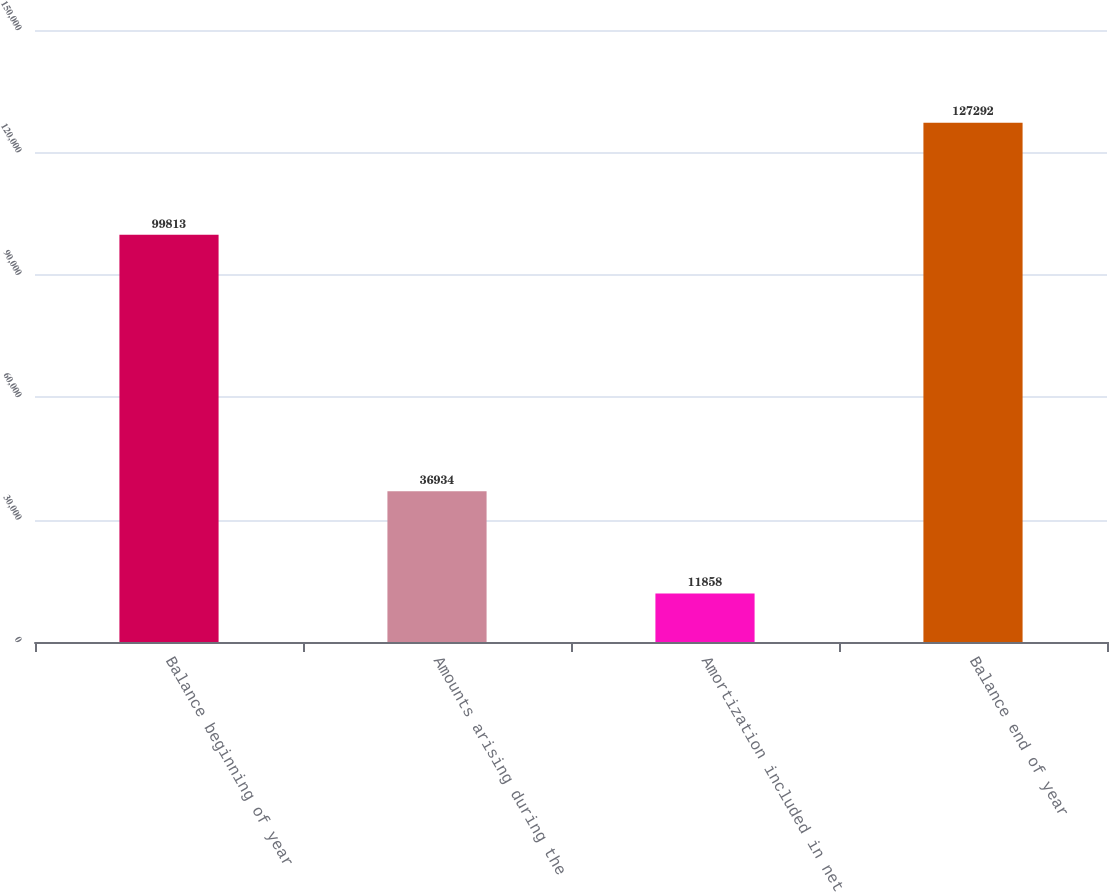<chart> <loc_0><loc_0><loc_500><loc_500><bar_chart><fcel>Balance beginning of year<fcel>Amounts arising during the<fcel>Amortization included in net<fcel>Balance end of year<nl><fcel>99813<fcel>36934<fcel>11858<fcel>127292<nl></chart> 